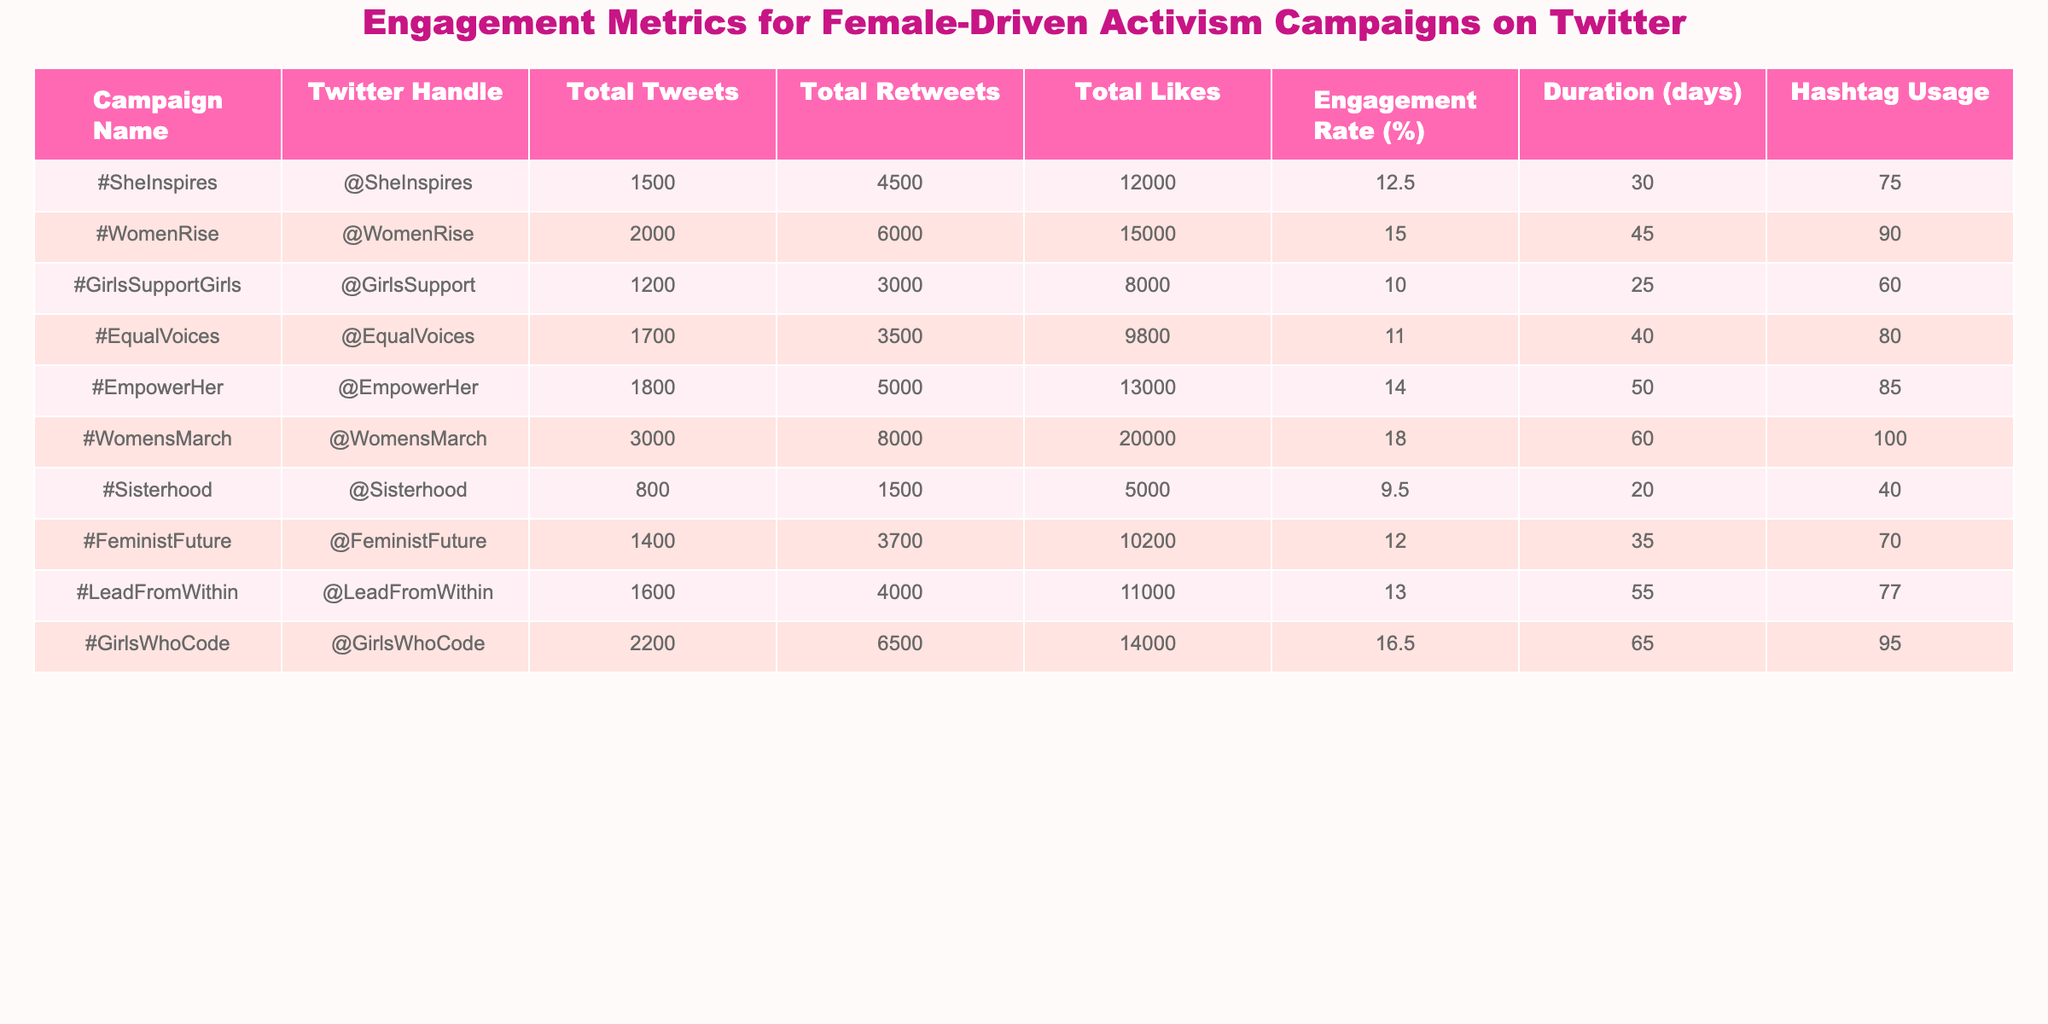What is the campaign with the highest engagement rate? By looking at the "Engagement Rate (%)" column, #WomensMarch has the highest value at 18.0%.
Answer: #WomensMarch How many total likes did the #EmpowerHer campaign receive? The "Total Likes" column for #EmpowerHer shows 13,000.
Answer: 13,000 What is the total number of tweets across all campaigns? To find this, sum the "Total Tweets" column: 1500 + 2000 + 1200 + 1700 + 1800 + 3000 + 800 + 1400 + 1600 + 2200 = 16,400.
Answer: 16,400 Which campaign had the lowest total retweets? Looking at the "Total Retweets" column, #Sisterhood has the lowest at 1,500.
Answer: #Sisterhood Are there any campaigns that have both an engagement rate of 15% or higher and at least 6,000 total retweets? Checking the campaigns, both #WomenRise and #WomensMarch meet these conditions with engagement rates of 15.0% and 18.0%, respectively, and have more than 6,000 retweets.
Answer: Yes Which campaign had the longest duration, and what was that duration? The "Duration (days)" column shows that #WomensMarch has the longest duration of 60 days.
Answer: #WomensMarch, 60 days What is the average engagement rate of all campaigns? To calculate the average, sum the engagement rates and divide by the number of campaigns: (12.5 + 15.0 + 10.0 + 11.0 + 14.0 + 18.0 + 9.5 + 12.0 + 13.0 + 16.5) / 10 = 13.0%.
Answer: 13.0% Which hashtag was used the most frequently across all campaigns? Checking the "Hashtag Usage" column, #WomensMarch used the hashtag 100 times, which is the highest.
Answer: #WomensMarch What is the difference in total likes between #GirlsSupportGirls and #WomenRise? The total likes for #GirlsSupportGirls are 8,000 and for #WomenRise are 15,000. The difference is 15,000 - 8,000 = 7,000.
Answer: 7,000 Did the #LeadFromWithin campaign have more total likes than the #GirlsWhoCode campaign? Comparing both campaigns, #LeadFromWithin has 11,000 total likes, while #GirlsWhoCode has 14,000. Therefore, #LeadFromWithin has fewer total likes.
Answer: No 